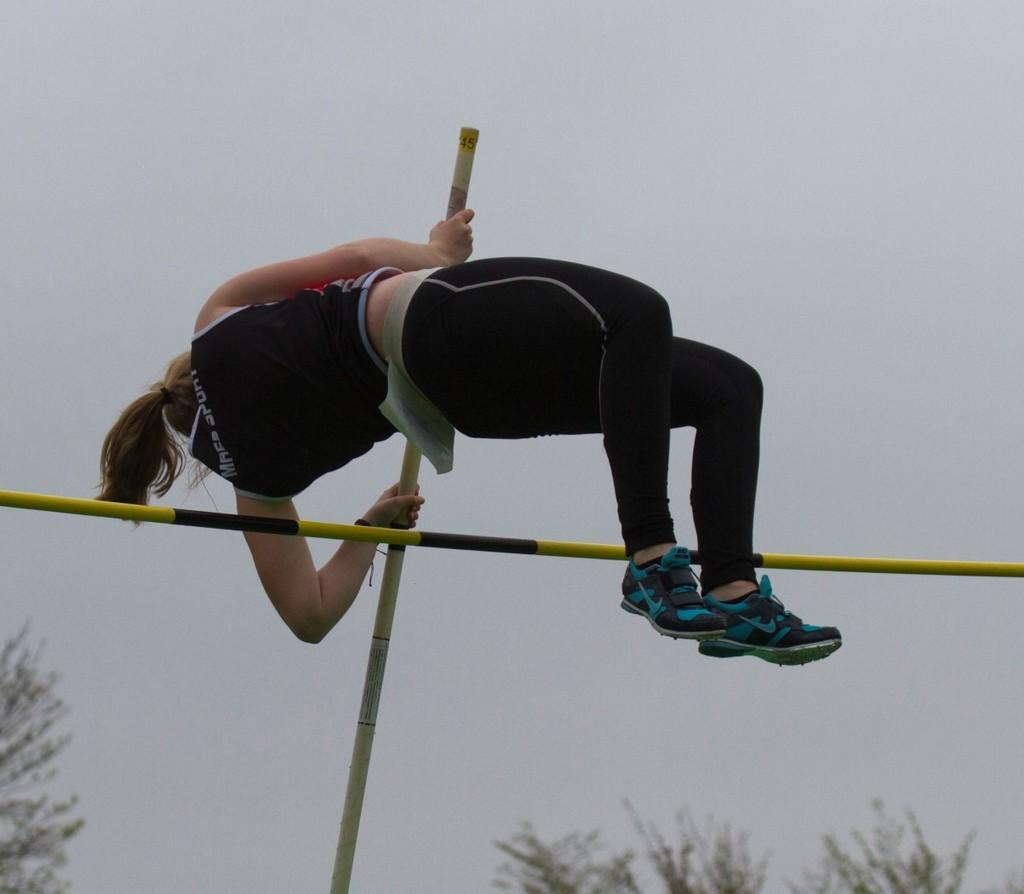Could you give a brief overview of what you see in this image? In the center of the image we can see woman is jumping. In the background we can see trees and sky. 